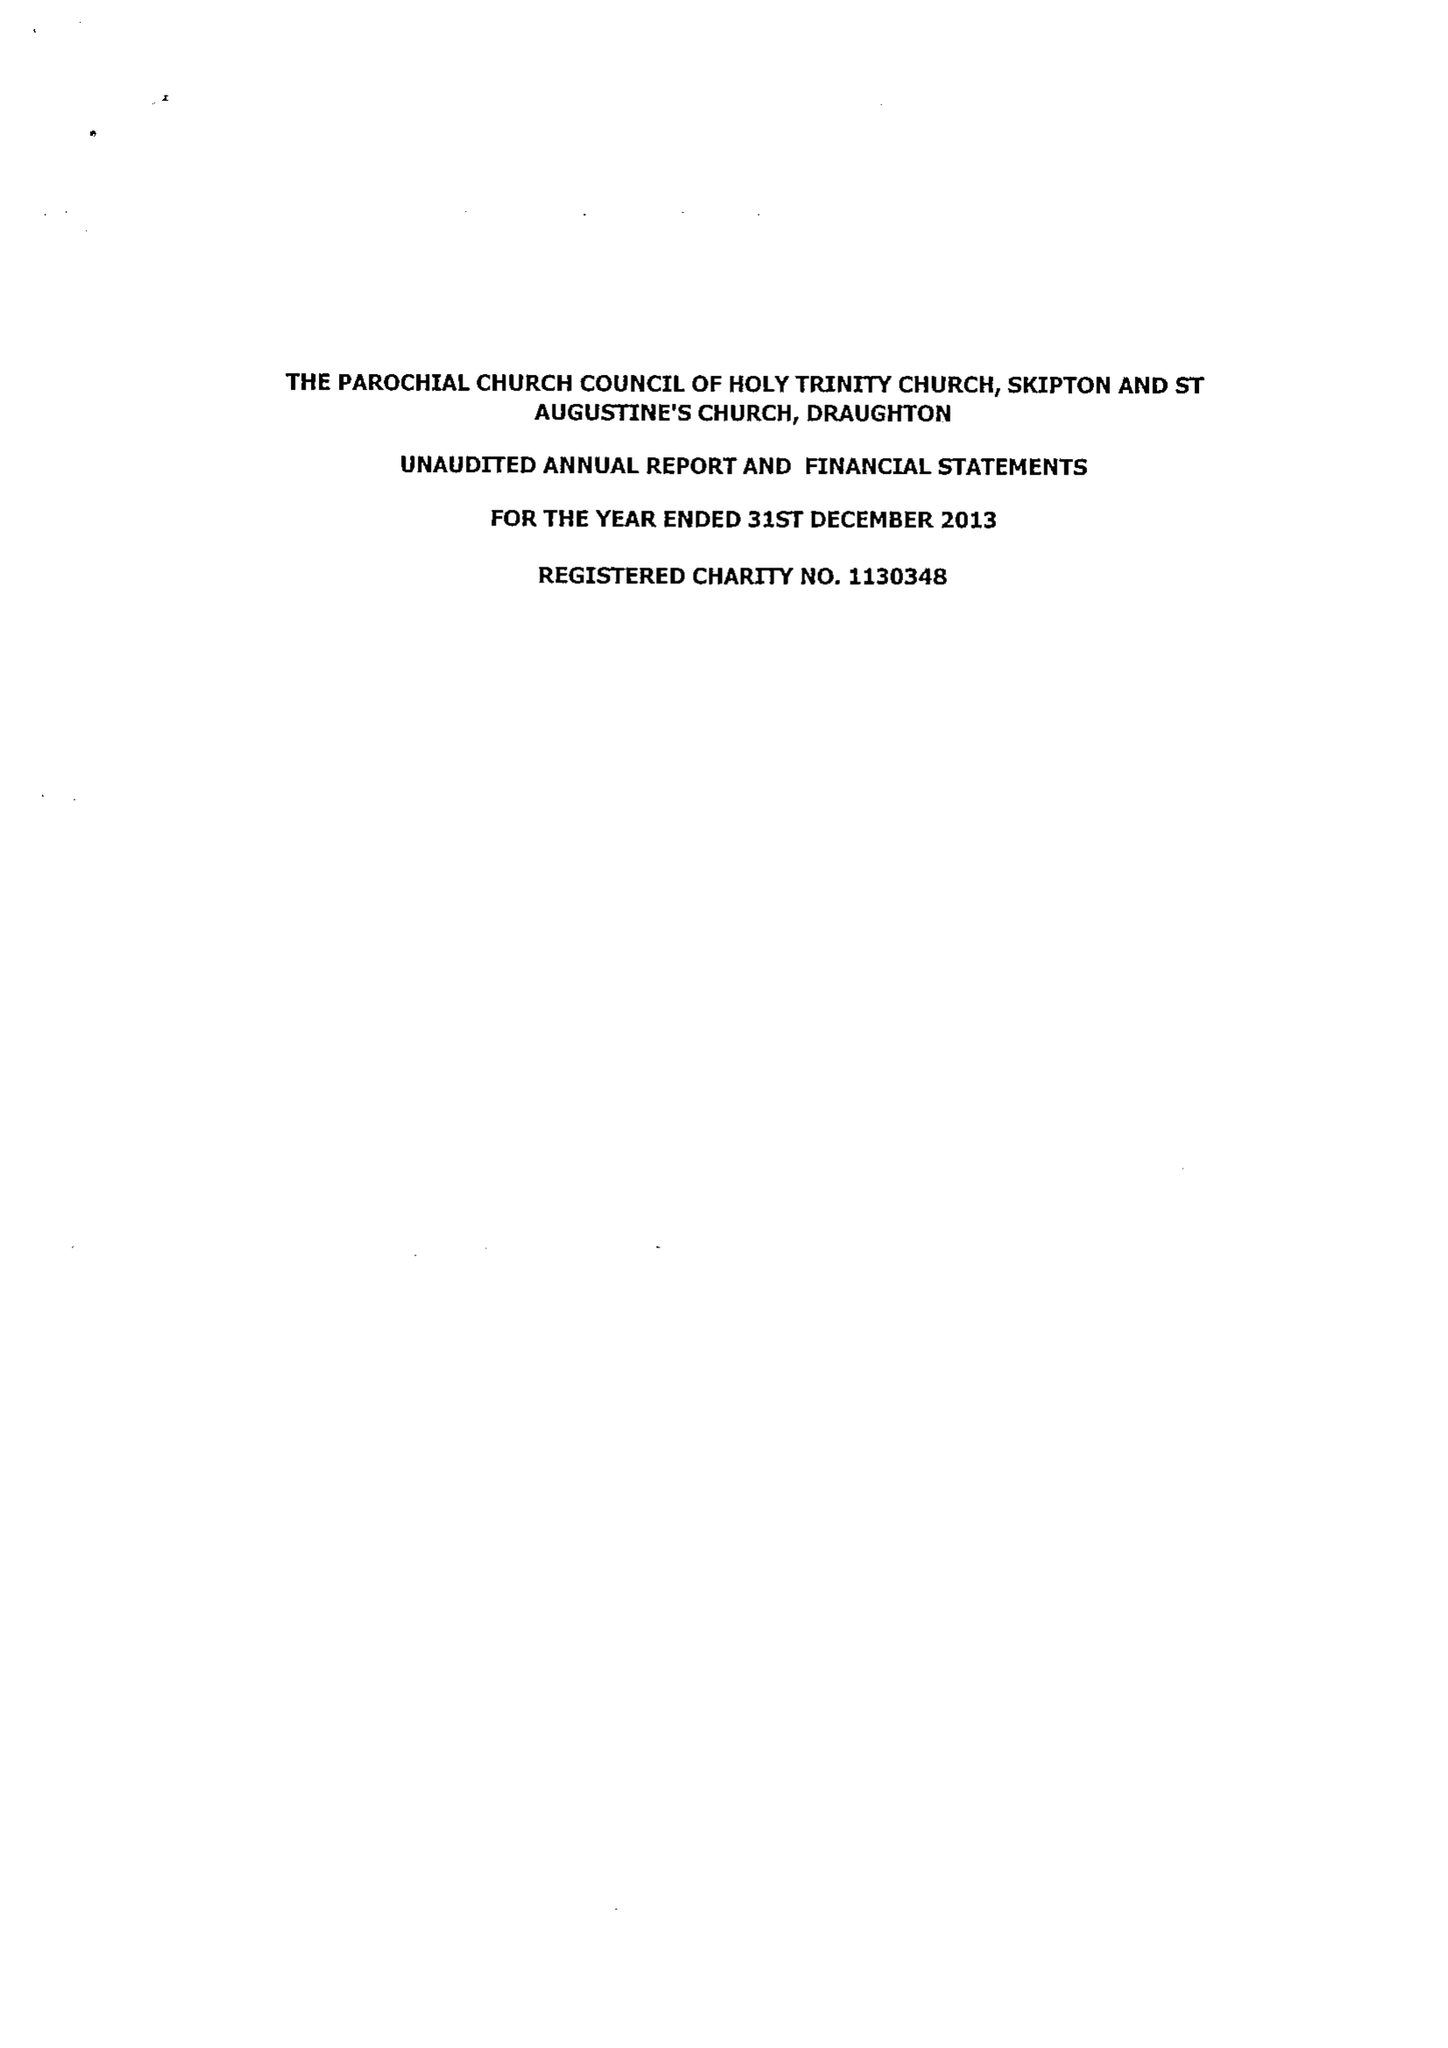What is the value for the address__street_line?
Answer the question using a single word or phrase. 8 RAIKESWOOD DRIVE 